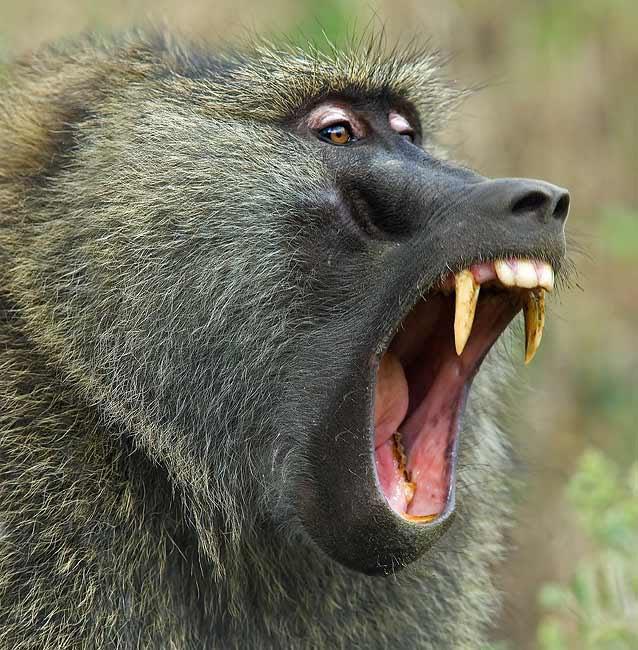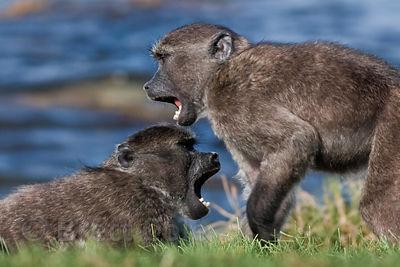The first image is the image on the left, the second image is the image on the right. Evaluate the accuracy of this statement regarding the images: "There are at least three animals in the image on the left.". Is it true? Answer yes or no. No. 